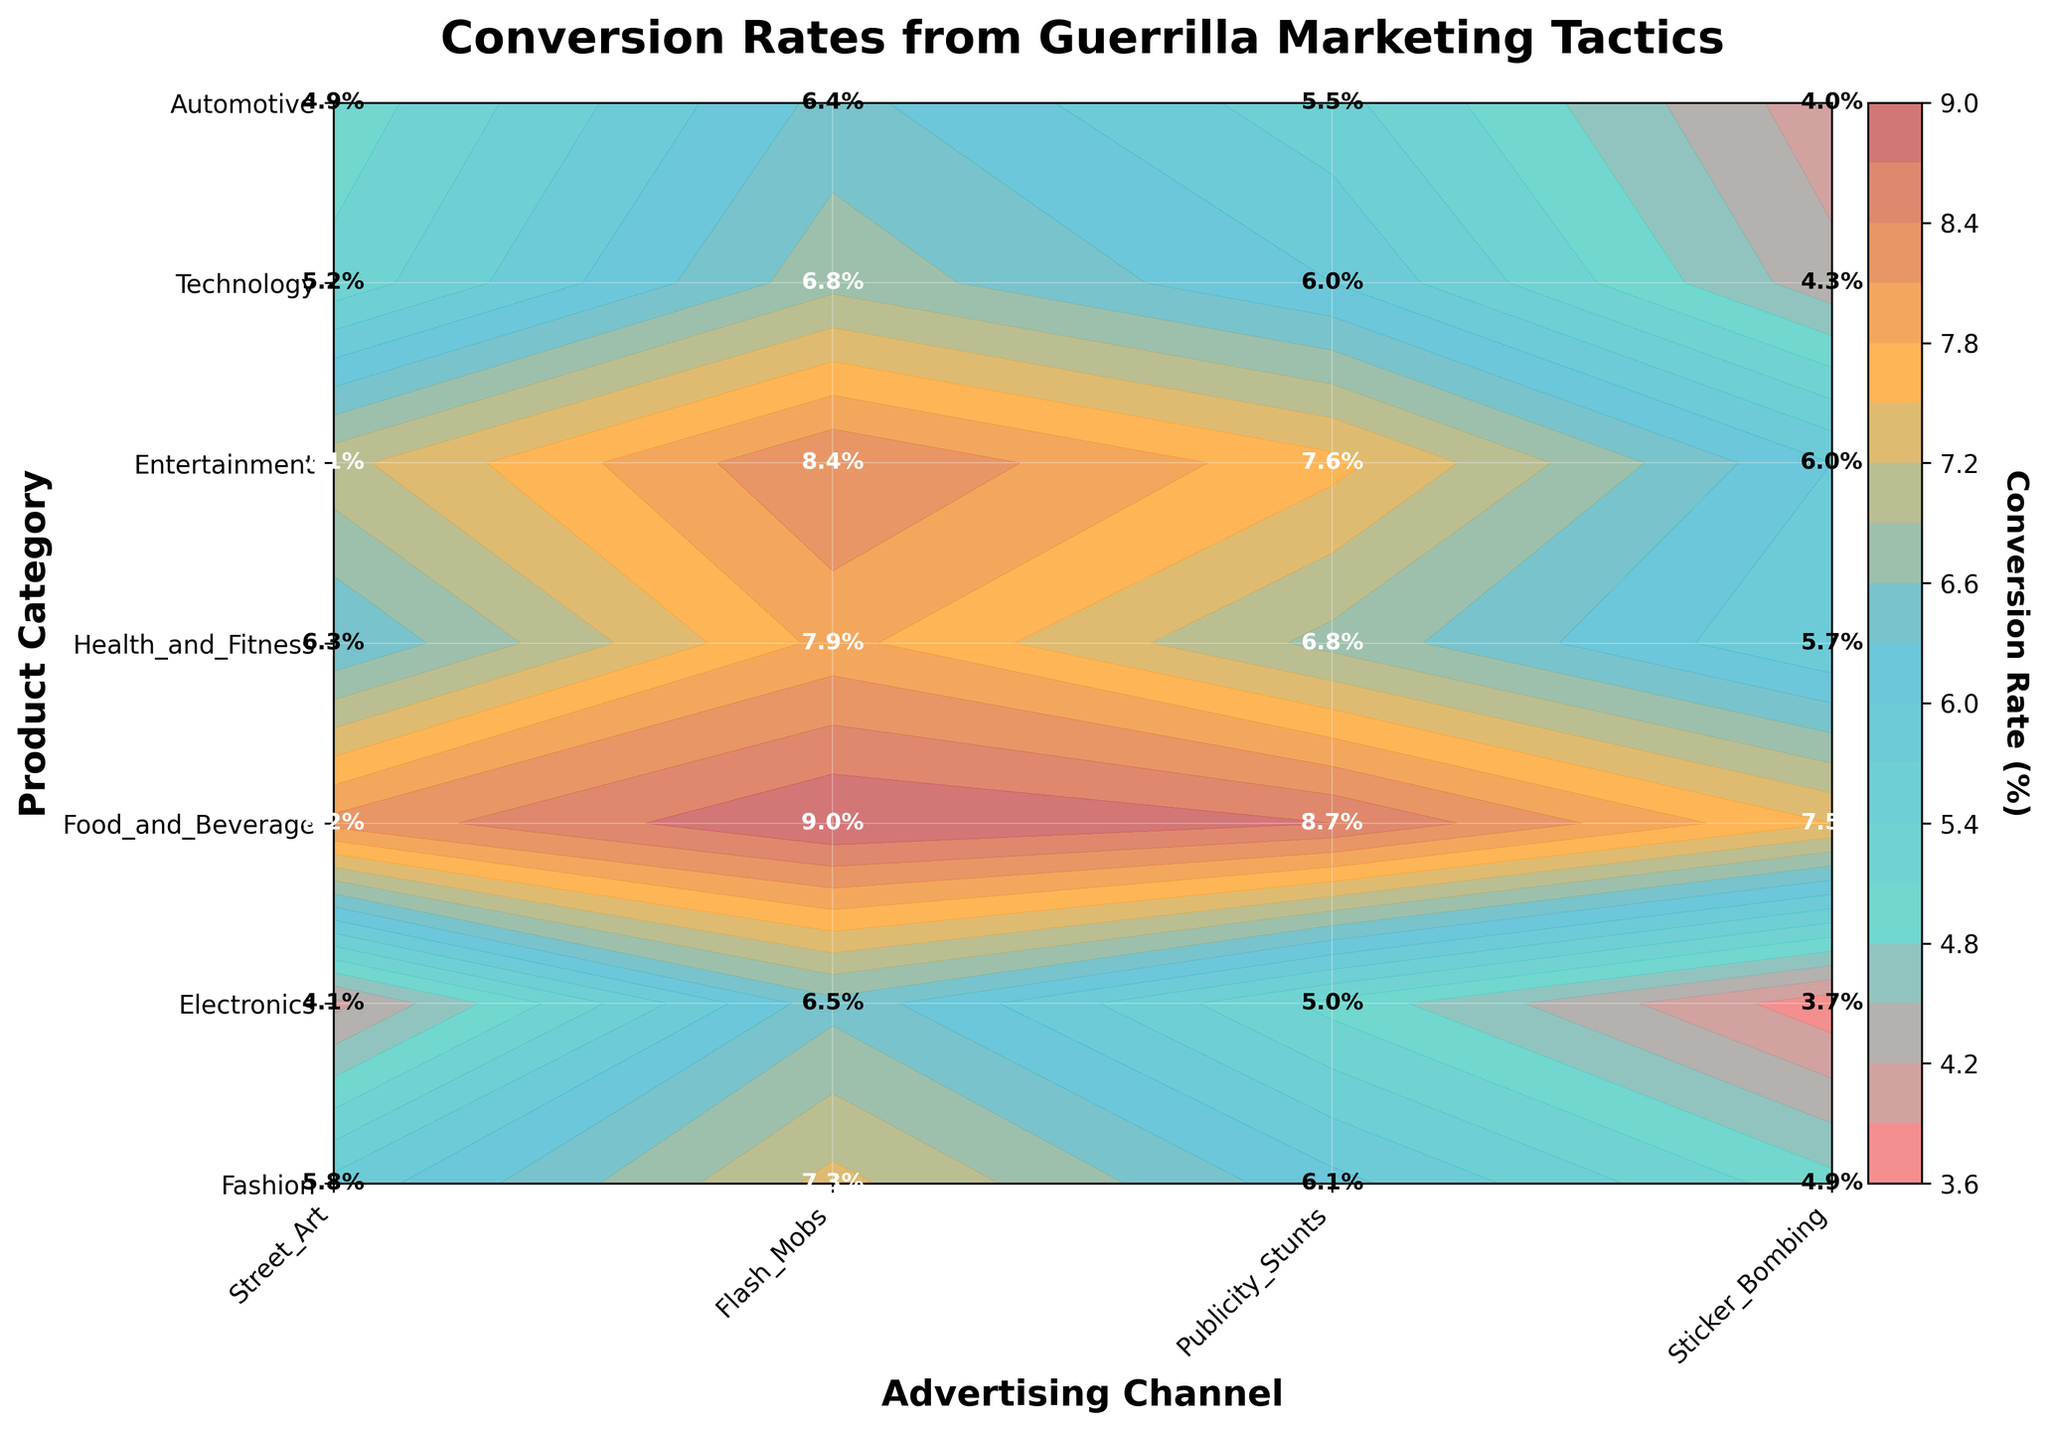What is the title of the plot? The title is located at the top of the plot, usually in bold and larger font than the other text. It provides a concise description of what the plot represents. In this case, it reads "Conversion Rates from Guerrilla Marketing Tactics".
Answer: Conversion Rates from Guerrilla Marketing Tactics What is the highest conversion rate for Street Art and in which product category is it observed? To find the highest conversion rate for Street Art, look along the Street Art row and identify the highest rate. In this case, the highest conversion rate for Street Art is 8.2%, observed in the Food and Beverage category.
Answer: 8.2%, Food and Beverage Which advertising channel has the lowest conversion rate in Technology? To answer this, locate the Technology row and compare the conversion rates for each advertising channel. The lowest rate is 4.3%, which is for Sticker Bombing.
Answer: Sticker Bombing What is the average conversion rate for Flash Mobs across all product categories? Add the conversion rates for Flash Mobs across all categories and then divide by the number of categories. The rates are 7.3, 6.5, 9.0, 7.9, 8.4, 6.8, and 6.4. Summing these gives 52.3, and dividing by 7 yields an average of 7.47.
Answer: 7.47% Which product category has the most balanced conversion rates across all advertising channels? A balanced conversion rate means the values should be close to each other. Comparing the rates for each category, Fashion has rates of 5.8, 7.3, 6.1, and 4.9. Electronics and Automotive have broader ranges, whereas categories like Food and Beverage, Health and Fitness, Entertainment, and Technology show more variation. Thus, Fashion is the most balanced.
Answer: Fashion How much higher is the conversion rate for Flash Mobs compared to Publicity Stunts in Health and Fitness? To determine this, subtract the conversion rate for Publicity Stunts from Flash Mobs in Health and Fitness. Flash Mobs have a rate of 7.9% and Publicity Stunts have 6.8%, so the difference is 7.9 - 6.8 = 1.1%.
Answer: 1.1% Which combination of product category and advertising channel has the highest conversion rate overall? By scanning through all values in the contour plot, the highest rate is found in the Food and Beverage category with Flash Mob with a conversion rate of 9.0%.
Answer: Food and Beverage with Flash Mob How do conversion rates for Electronics in Sticker Bombing compare to those for Automotive in Sticker Bombing? Identify the conversion rates for both categories in Sticker Bombing. Electronics have a conversion rate of 3.7%, whereas Automotive has 4.0%. Hence, Automotive is slightly higher.
Answer: Automotive is higher What is the average conversion rate for Publicity Stunts across all product categories? Add all the conversion rates for Publicity Stunts for each category: 6.1, 5.0, 8.7, 6.8, 7.6, 6.0, and 5.5. Summing these gives 45.7, which divided by 7 gives approximately 6.53%.
Answer: 6.53% 